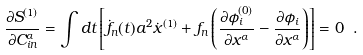<formula> <loc_0><loc_0><loc_500><loc_500>\frac { \partial S ^ { ( 1 ) } } { \partial C _ { i n } ^ { \alpha } } = \int d t \left [ \dot { f } _ { n } ( t ) a ^ { 2 } \dot { x } ^ { ( 1 ) } + f _ { n } \left ( \frac { \partial \phi ^ { ( 0 ) } _ { i } } { \partial x ^ { \alpha } } - \frac { \partial \phi _ { i } } { \partial x ^ { \alpha } } \right ) \right ] = 0 \ .</formula> 